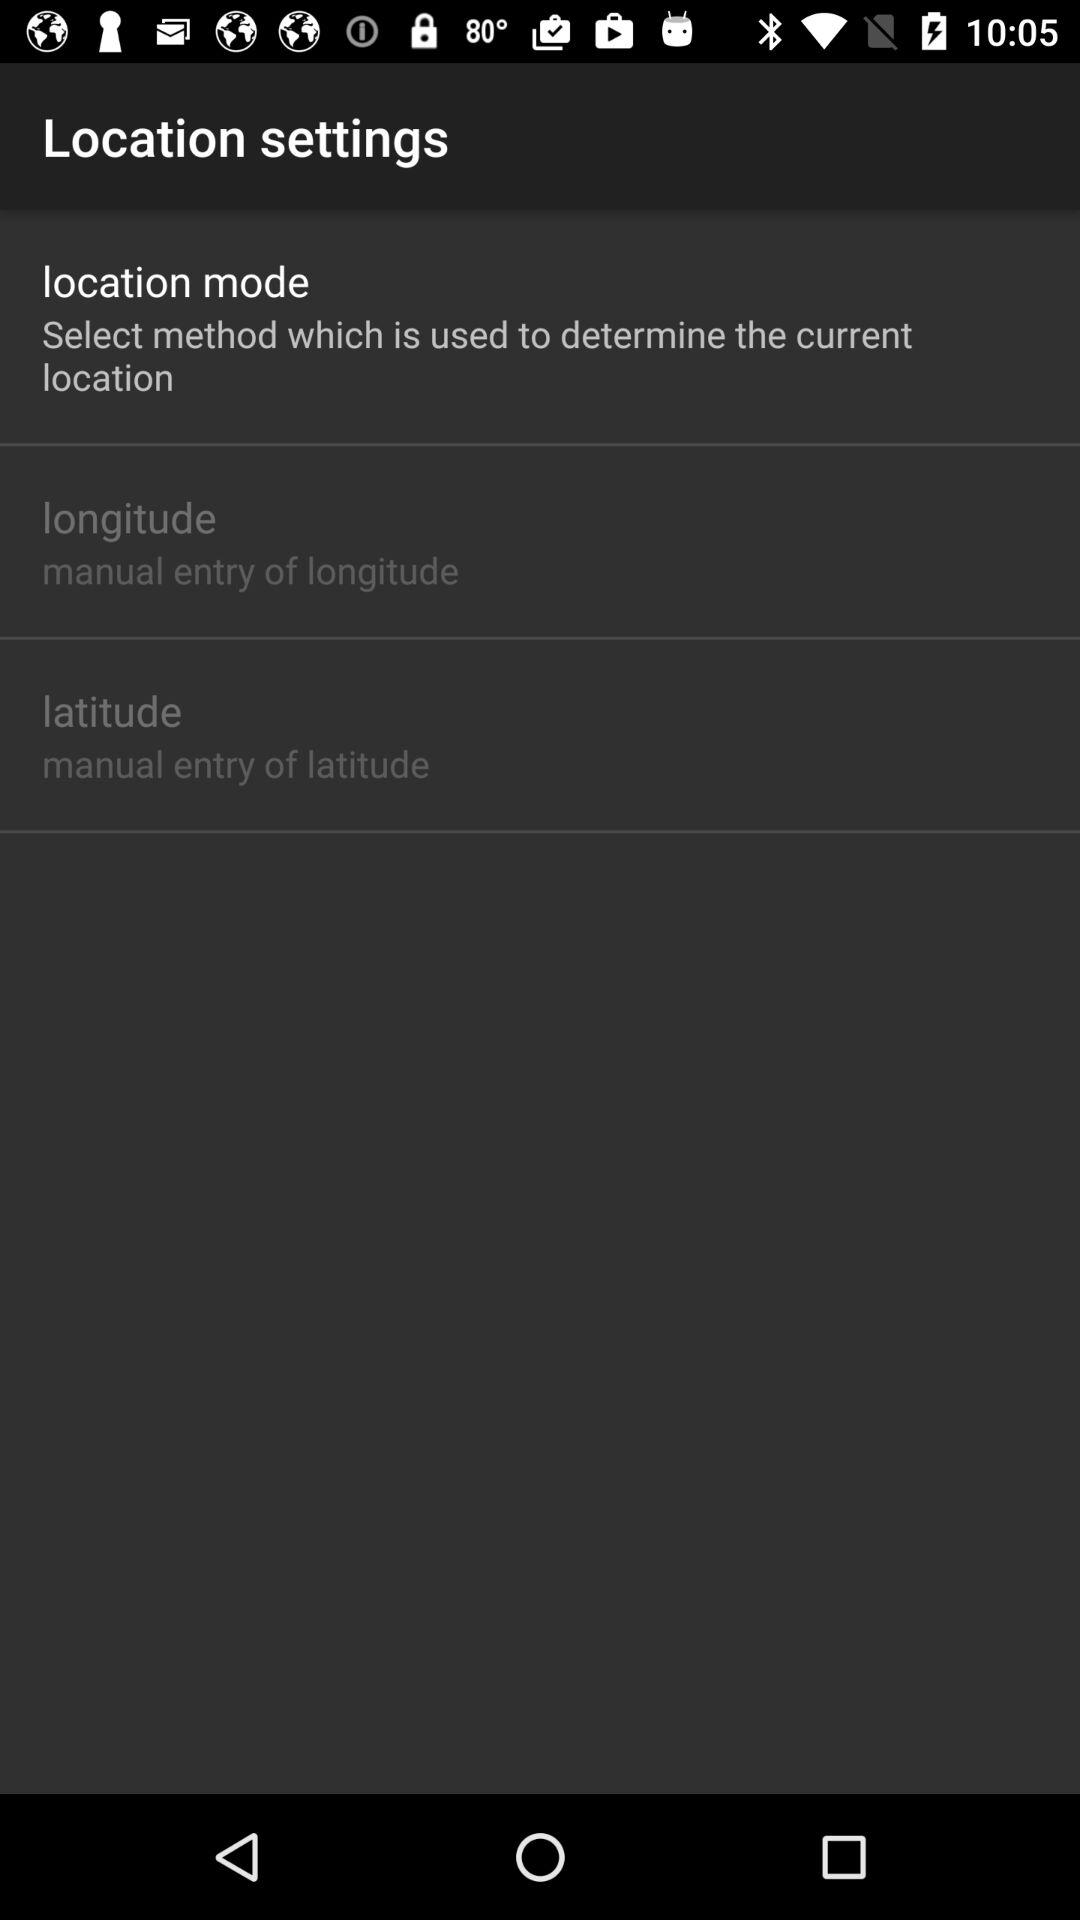How do I enter longitude? You can manually enter longitude. 